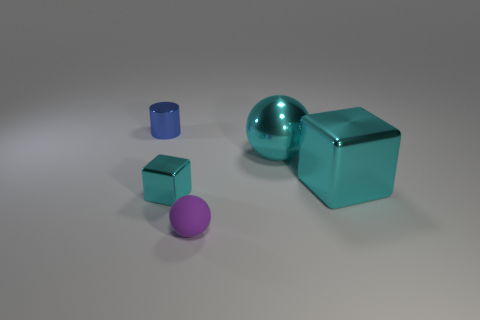Subtract all blue blocks. Subtract all gray cylinders. How many blocks are left? 2 Add 2 small gray shiny objects. How many objects exist? 7 Subtract all cylinders. How many objects are left? 4 Add 3 blue cylinders. How many blue cylinders are left? 4 Add 3 matte objects. How many matte objects exist? 4 Subtract 0 cyan cylinders. How many objects are left? 5 Subtract all metal balls. Subtract all small objects. How many objects are left? 1 